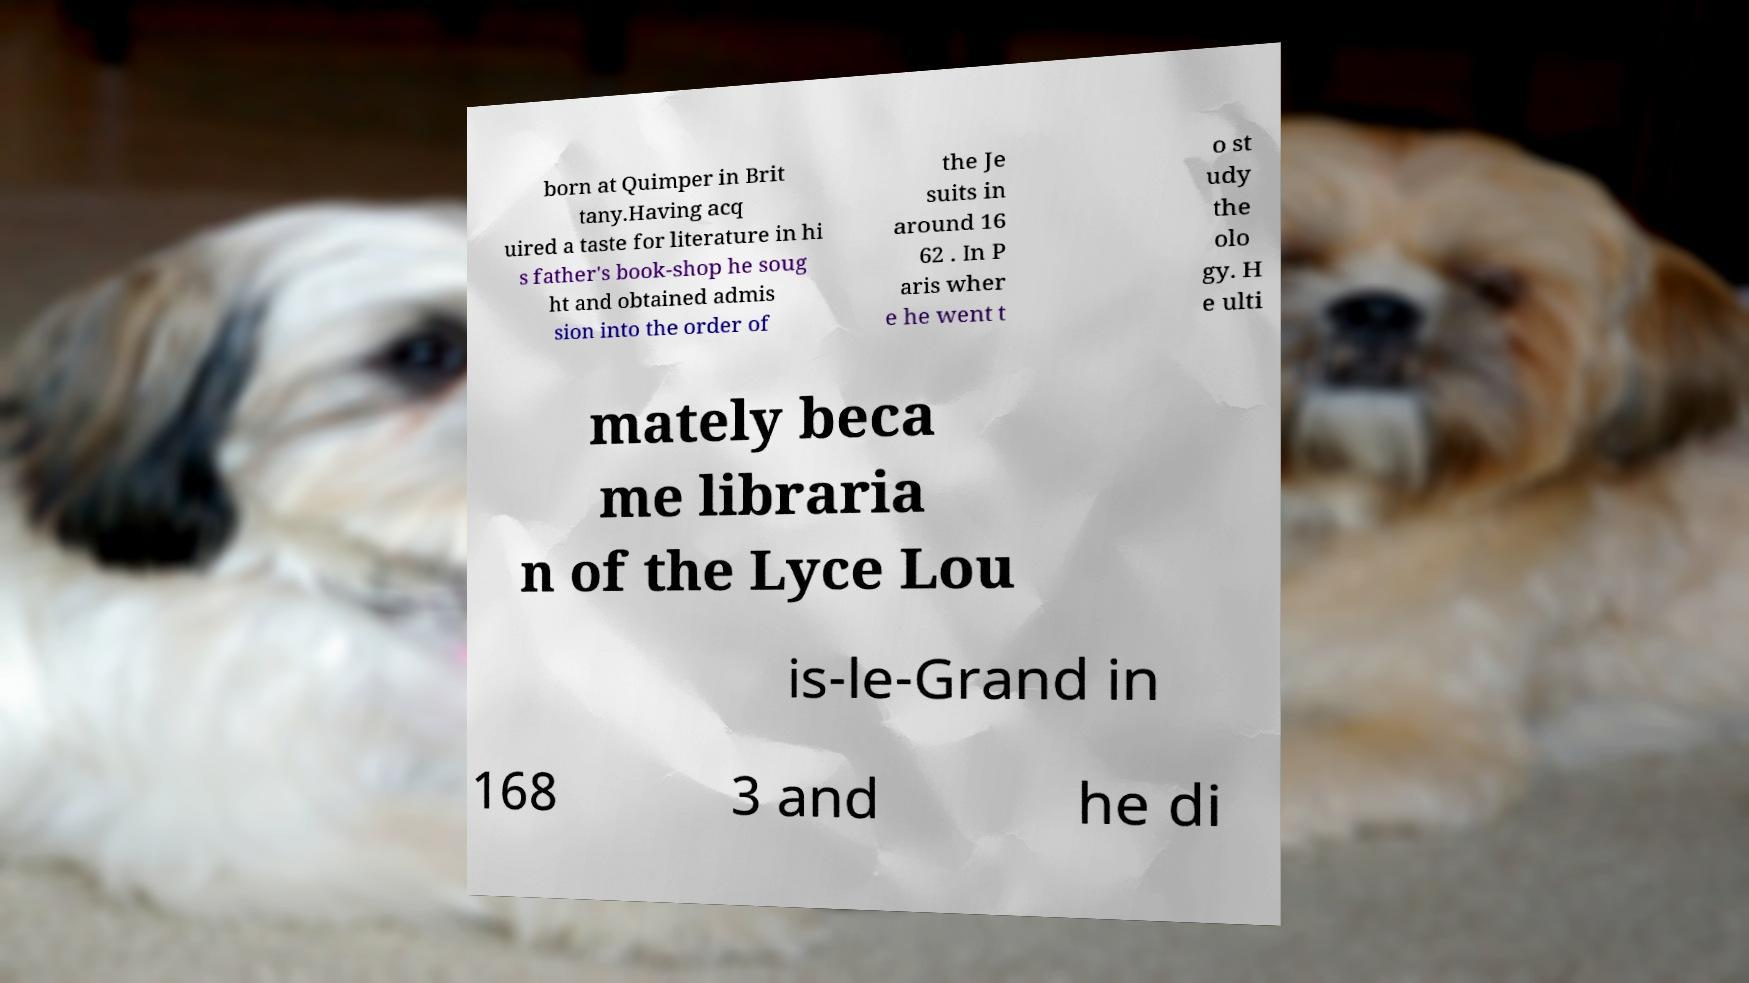Please read and relay the text visible in this image. What does it say? born at Quimper in Brit tany.Having acq uired a taste for literature in hi s father's book-shop he soug ht and obtained admis sion into the order of the Je suits in around 16 62 . In P aris wher e he went t o st udy the olo gy. H e ulti mately beca me libraria n of the Lyce Lou is-le-Grand in 168 3 and he di 